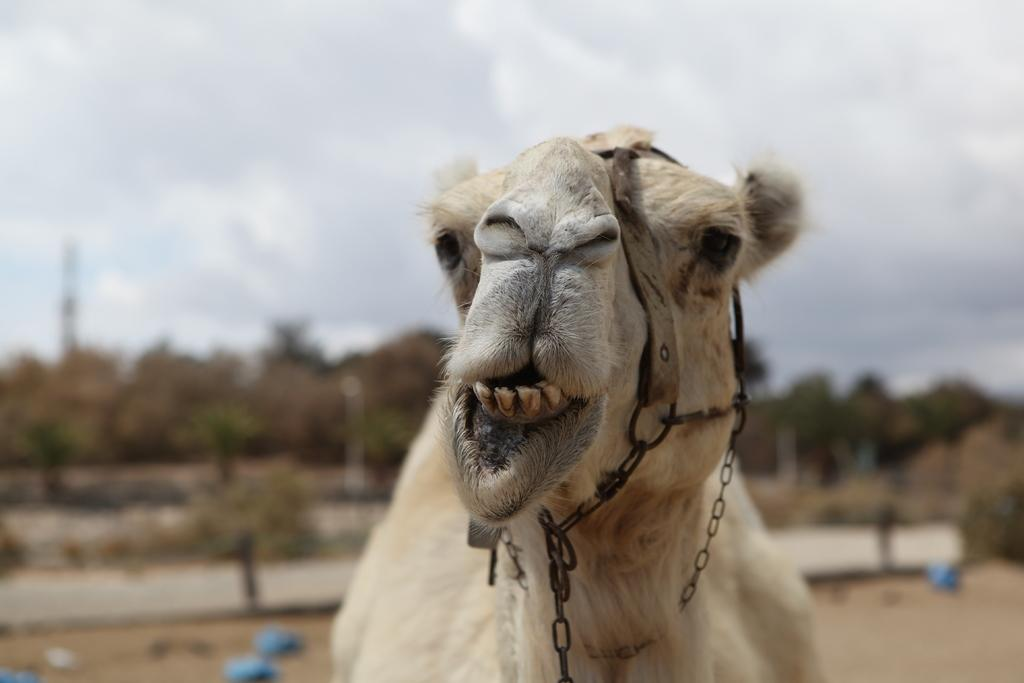What animal is present in the image? There is a camel in the image. What color is the camel? The camel is brown in color. How would you describe the sky in the image? The sky is cloudy in the image. What type of news can be heard coming from the camel's hump in the image? There is no indication in the image that the camel is producing or transmitting any news, so it cannot be determined from the picture. 